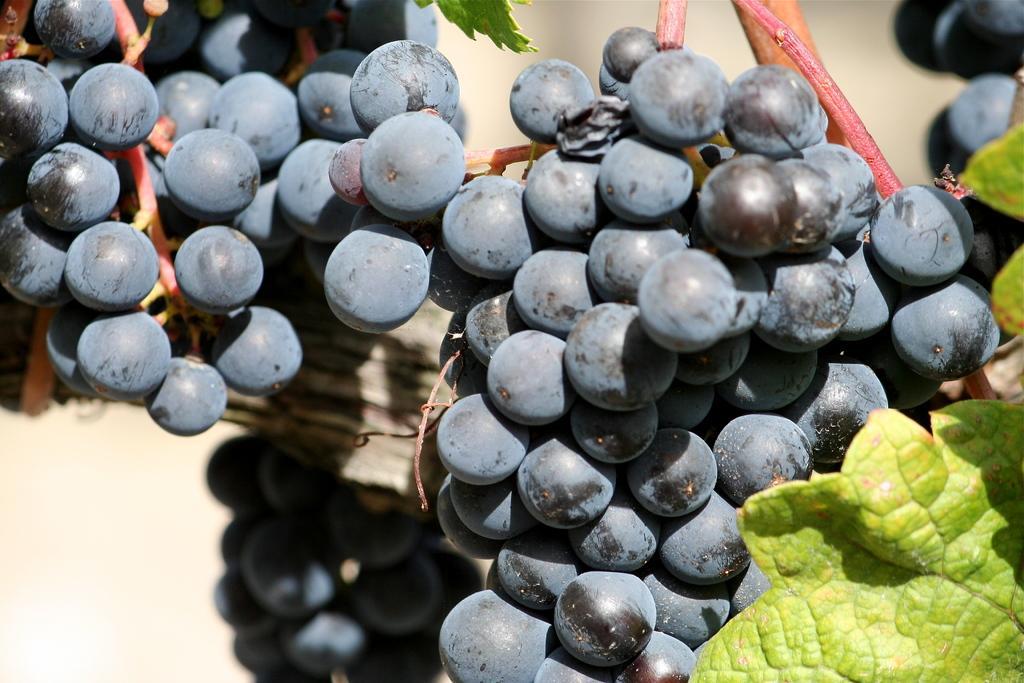Can you describe this image briefly? In this image there are grapes and there are leaves. 